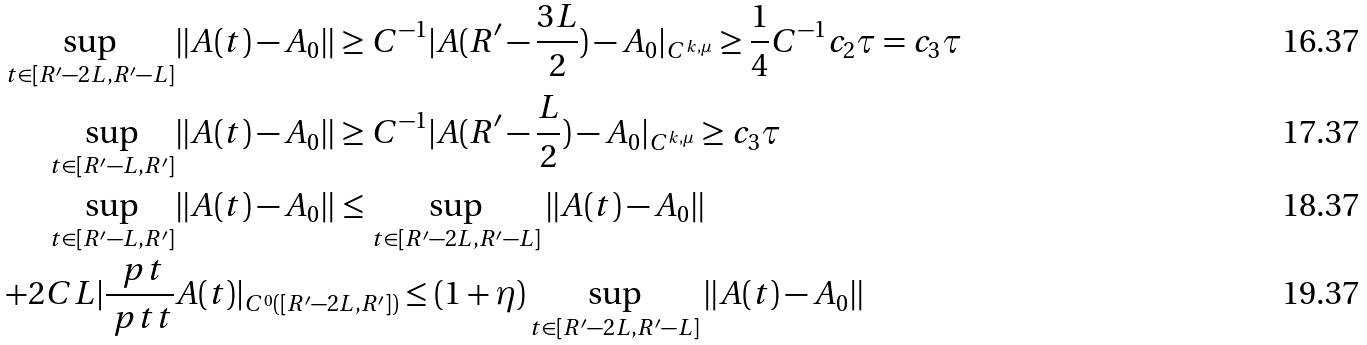<formula> <loc_0><loc_0><loc_500><loc_500>\sup _ { t \in [ R ^ { \prime } - 2 L , R ^ { \prime } - L ] } & \| A ( t ) - A _ { 0 } \| \geq C ^ { - 1 } | A ( R ^ { \prime } - \frac { 3 L } { 2 } ) - A _ { 0 } | _ { C ^ { k , \mu } } \geq \frac { 1 } { 4 } C ^ { - 1 } c _ { 2 } \tau = c _ { 3 } \tau \\ \sup _ { t \in [ R ^ { \prime } - L , R ^ { \prime } ] } & \| A ( t ) - A _ { 0 } \| \geq C ^ { - 1 } | A ( R ^ { \prime } - \frac { L } { 2 } ) - A _ { 0 } | _ { C ^ { k , \mu } } \geq c _ { 3 } \tau \\ \sup _ { t \in [ R ^ { \prime } - L , R ^ { \prime } ] } & \| A ( t ) - A _ { 0 } \| \leq \sup _ { t \in [ R ^ { \prime } - 2 L , R ^ { \prime } - L ] } \| A ( t ) - A _ { 0 } \| \\ \quad + 2 C L | \frac { \ p t } { \ p t t } & A ( t ) | _ { C ^ { 0 } ( [ R ^ { \prime } - 2 L , R ^ { \prime } ] ) } \leq ( 1 + \eta ) \sup _ { t \in [ R ^ { \prime } - 2 L , R ^ { \prime } - L ] } \| A ( t ) - A _ { 0 } \|</formula> 